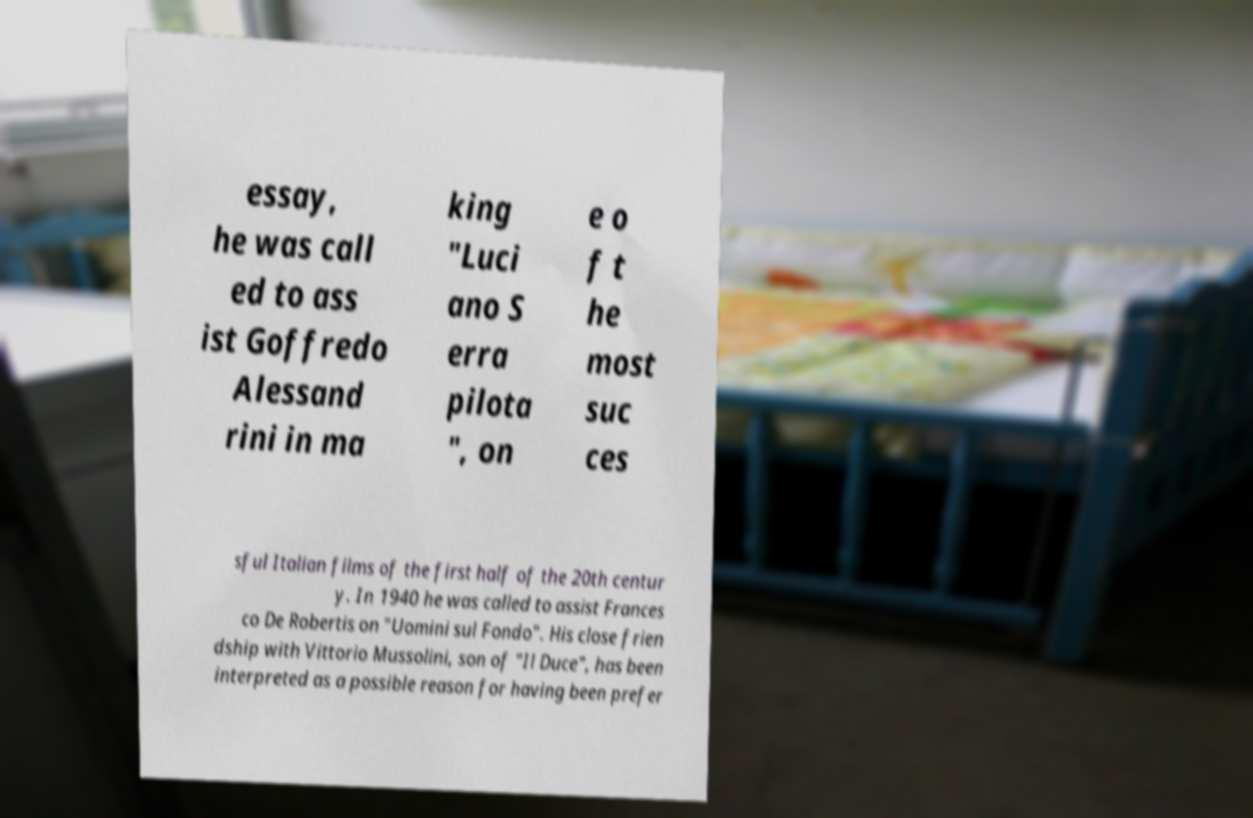There's text embedded in this image that I need extracted. Can you transcribe it verbatim? essay, he was call ed to ass ist Goffredo Alessand rini in ma king "Luci ano S erra pilota ", on e o f t he most suc ces sful Italian films of the first half of the 20th centur y. In 1940 he was called to assist Frances co De Robertis on "Uomini sul Fondo". His close frien dship with Vittorio Mussolini, son of "Il Duce", has been interpreted as a possible reason for having been prefer 